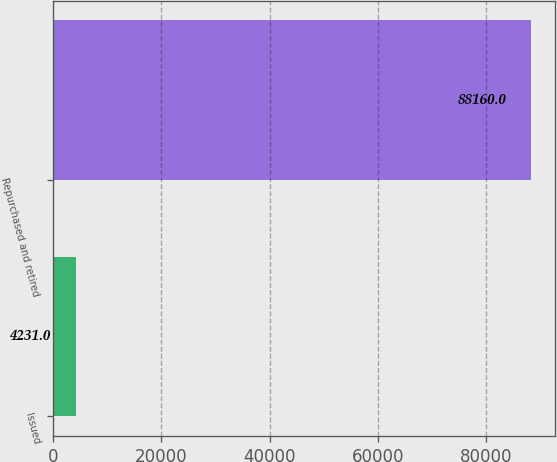Convert chart to OTSL. <chart><loc_0><loc_0><loc_500><loc_500><bar_chart><fcel>Issued<fcel>Repurchased and retired<nl><fcel>4231<fcel>88160<nl></chart> 